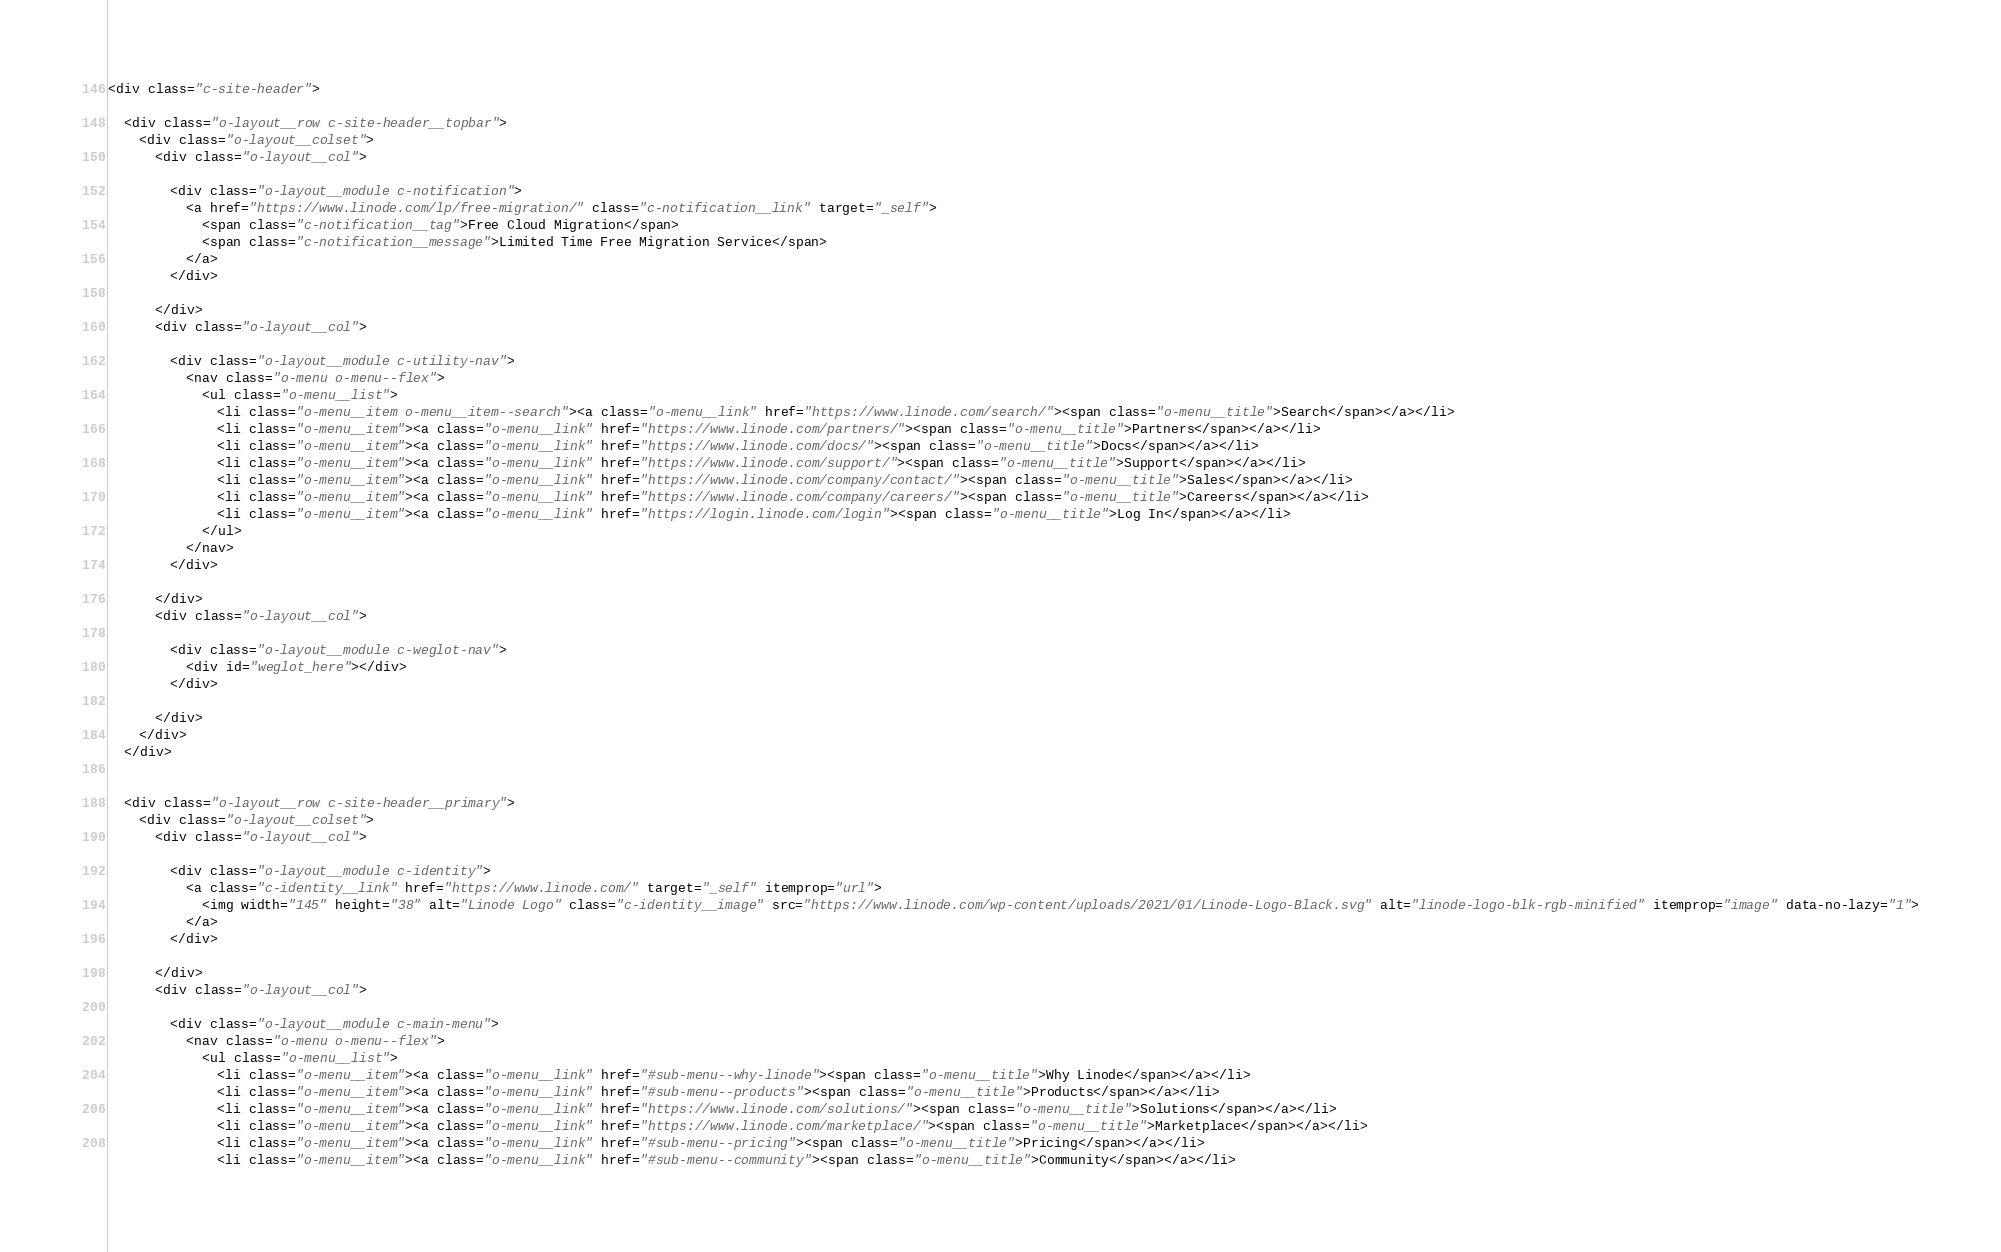Convert code to text. <code><loc_0><loc_0><loc_500><loc_500><_HTML_><div class="c-site-header">

  <div class="o-layout__row c-site-header__topbar">
    <div class="o-layout__colset">
      <div class="o-layout__col">

        <div class="o-layout__module c-notification">
          <a href="https://www.linode.com/lp/free-migration/" class="c-notification__link" target="_self">
            <span class="c-notification__tag">Free Cloud Migration</span>
            <span class="c-notification__message">Limited Time Free Migration Service</span>
          </a>
        </div>

      </div>
      <div class="o-layout__col">

        <div class="o-layout__module c-utility-nav">
          <nav class="o-menu o-menu--flex">
            <ul class="o-menu__list">
              <li class="o-menu__item o-menu__item--search"><a class="o-menu__link" href="https://www.linode.com/search/"><span class="o-menu__title">Search</span></a></li>
              <li class="o-menu__item"><a class="o-menu__link" href="https://www.linode.com/partners/"><span class="o-menu__title">Partners</span></a></li>
              <li class="o-menu__item"><a class="o-menu__link" href="https://www.linode.com/docs/"><span class="o-menu__title">Docs</span></a></li>
              <li class="o-menu__item"><a class="o-menu__link" href="https://www.linode.com/support/"><span class="o-menu__title">Support</span></a></li>
              <li class="o-menu__item"><a class="o-menu__link" href="https://www.linode.com/company/contact/"><span class="o-menu__title">Sales</span></a></li>
              <li class="o-menu__item"><a class="o-menu__link" href="https://www.linode.com/company/careers/"><span class="o-menu__title">Careers</span></a></li>
              <li class="o-menu__item"><a class="o-menu__link" href="https://login.linode.com/login"><span class="o-menu__title">Log In</span></a></li>
            </ul>
          </nav>
        </div>

      </div>
      <div class="o-layout__col">

        <div class="o-layout__module c-weglot-nav">
          <div id="weglot_here"></div>
        </div>

      </div>
    </div>
  </div>


  <div class="o-layout__row c-site-header__primary">
    <div class="o-layout__colset">
      <div class="o-layout__col">

        <div class="o-layout__module c-identity">
          <a class="c-identity__link" href="https://www.linode.com/" target="_self" itemprop="url">
            <img width="145" height="38" alt="Linode Logo" class="c-identity__image" src="https://www.linode.com/wp-content/uploads/2021/01/Linode-Logo-Black.svg" alt="linode-logo-blk-rgb-minified" itemprop="image" data-no-lazy="1">
          </a>
        </div>

      </div>
      <div class="o-layout__col">

        <div class="o-layout__module c-main-menu">
          <nav class="o-menu o-menu--flex">
            <ul class="o-menu__list">
              <li class="o-menu__item"><a class="o-menu__link" href="#sub-menu--why-linode"><span class="o-menu__title">Why Linode</span></a></li>
              <li class="o-menu__item"><a class="o-menu__link" href="#sub-menu--products"><span class="o-menu__title">Products</span></a></li>
              <li class="o-menu__item"><a class="o-menu__link" href="https://www.linode.com/solutions/"><span class="o-menu__title">Solutions</span></a></li>
              <li class="o-menu__item"><a class="o-menu__link" href="https://www.linode.com/marketplace/"><span class="o-menu__title">Marketplace</span></a></li>
              <li class="o-menu__item"><a class="o-menu__link" href="#sub-menu--pricing"><span class="o-menu__title">Pricing</span></a></li>
              <li class="o-menu__item"><a class="o-menu__link" href="#sub-menu--community"><span class="o-menu__title">Community</span></a></li></code> 